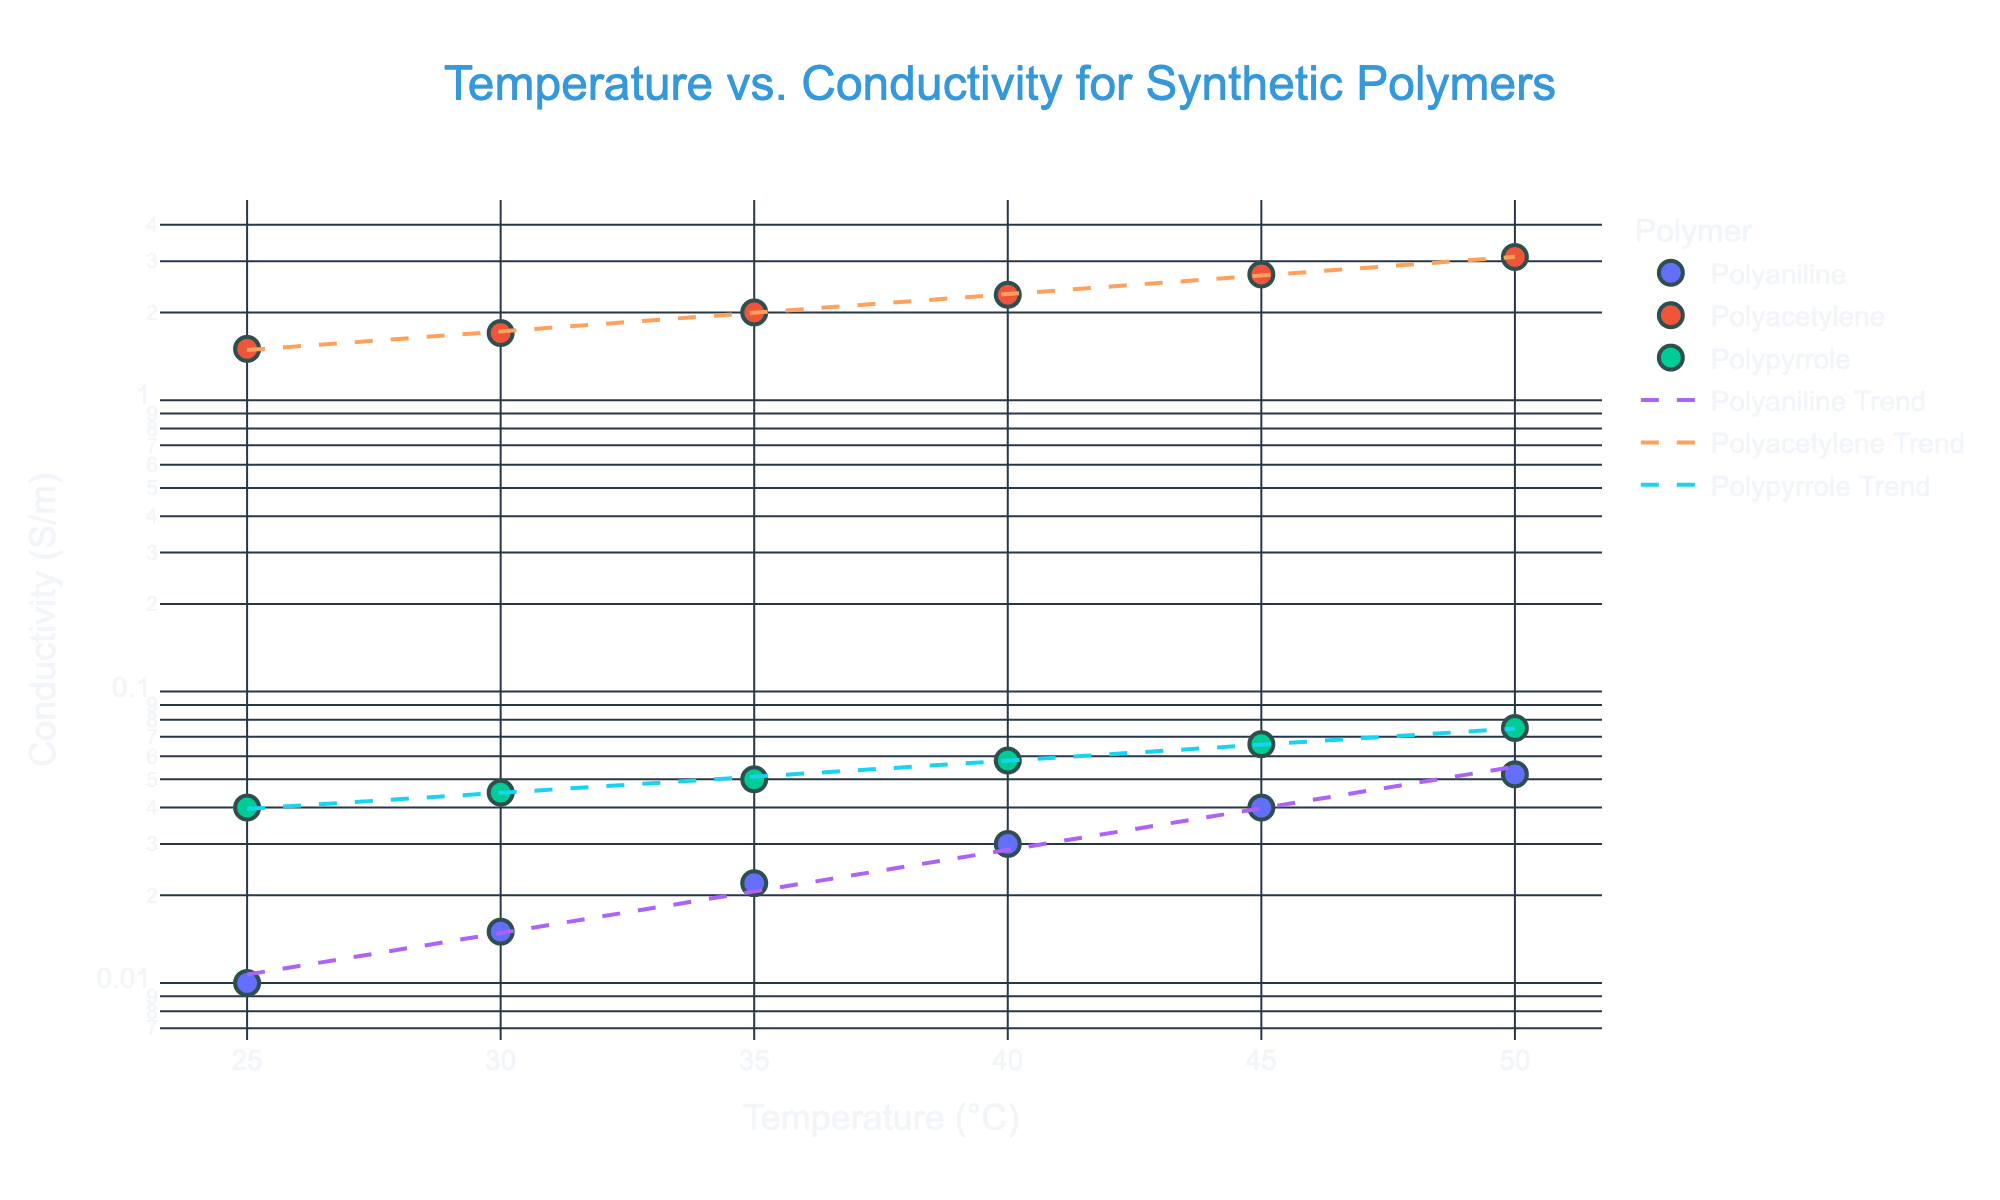What is the title of the scatter plot? The title of the scatter plot is located at the top center of the figure. It reads "Temperature vs. Conductivity for Synthetic Polymers"
Answer: Temperature vs. Conductivity for Synthetic Polymers What are the x-axis and y-axis labeled as? The x-axis label is found along the horizontal axis, and the y-axis label is found along the vertical axis. They are respectively labeled "Temperature (°C)" and "Conductivity (S/m)"
Answer: Temperature (°C); Conductivity (S/m) How many unique polymers are represented in the scatter plot? Each data point on the scatter plot is color-coded by polymer type, with three distinct colors denoting different polymers. The legend shows 3 different polymers: Polyaniline, Polyacetylene, and Polypyrrole
Answer: 3 Which polymer has the highest maximum conductivity? To determine the polymer with the highest maximum conductivity, look at the scatter plots' highest points on the y-axis and their corresponding polymer colors in the legend. The highest maximum conductivity is seen with the polymer Polyacetylene
Answer: Polyacetylene What trend is observed for Polyaniline as temperature increases? By following the trend line for Polyaniline, from lower to higher temperatures along the x-axis, observe the corresponding increase in conductivity levels on the y-axis. The trend line for Polyaniline consistently increases, indicating that conductivity increases with temperature
Answer: Conductivity increases Is the relationship between temperature and conductivity linear or non-linear for Polyacetylene? Observing the scatter plot and the trend line for Polyacetylene, the conductivity increases exponentially with temperature, which is evidenced by the curved nature of the trend line, suggesting a non-linear relationship
Answer: Non-linear How does the overall increase in conductivity from 25°C to 50°C differ between Polyaniline and Polypyrrole? Compare the increase in conductivity by finding the changes from 25°C to 50°C for both. For Polyaniline, it increases from 0.01 S/m to 0.052 S/m (0.052 - 0.01 = 0.042). For Polypyrrole, it increases from 0.04 S/m to 0.075 S/m (0.075 - 0.04 = 0.035). Polyaniline's overall increase is greater
Answer: Polyaniline's increase is greater Which polymer shows the least change in conductivity with temperature changes? Check the levels of conductivity from 25°C to 50°C for all polymers. Polypyrrole has the smallest range of change in conductivities (0.075 - 0.04 = 0.035 S/m), indicating the least change
Answer: Polypyrrole In the scatter plot, what is the logarithmic scaling effect on the y-axis? Since the y-axis (Conductivity) is logarithmically scaled, each unit increase on this axis represents an exponential increase in conductivity values, making it easier to distinguish changes over several orders of magnitude. This scaling helps to clearly see the data points despite a wide range in values
Answer: Exponential increase representation 